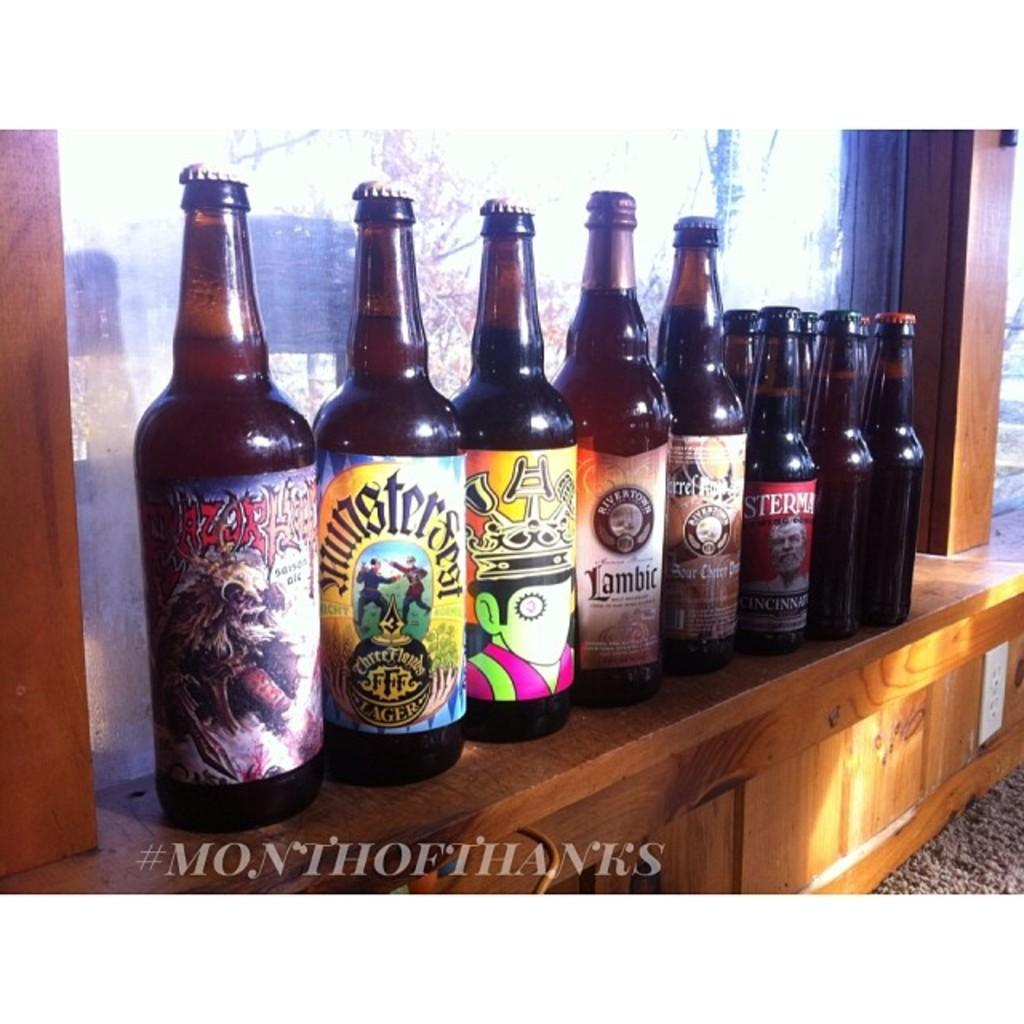Provide a one-sentence caption for the provided image. a row of alcohol bottles  with one that is labeled 'amsterman'. 